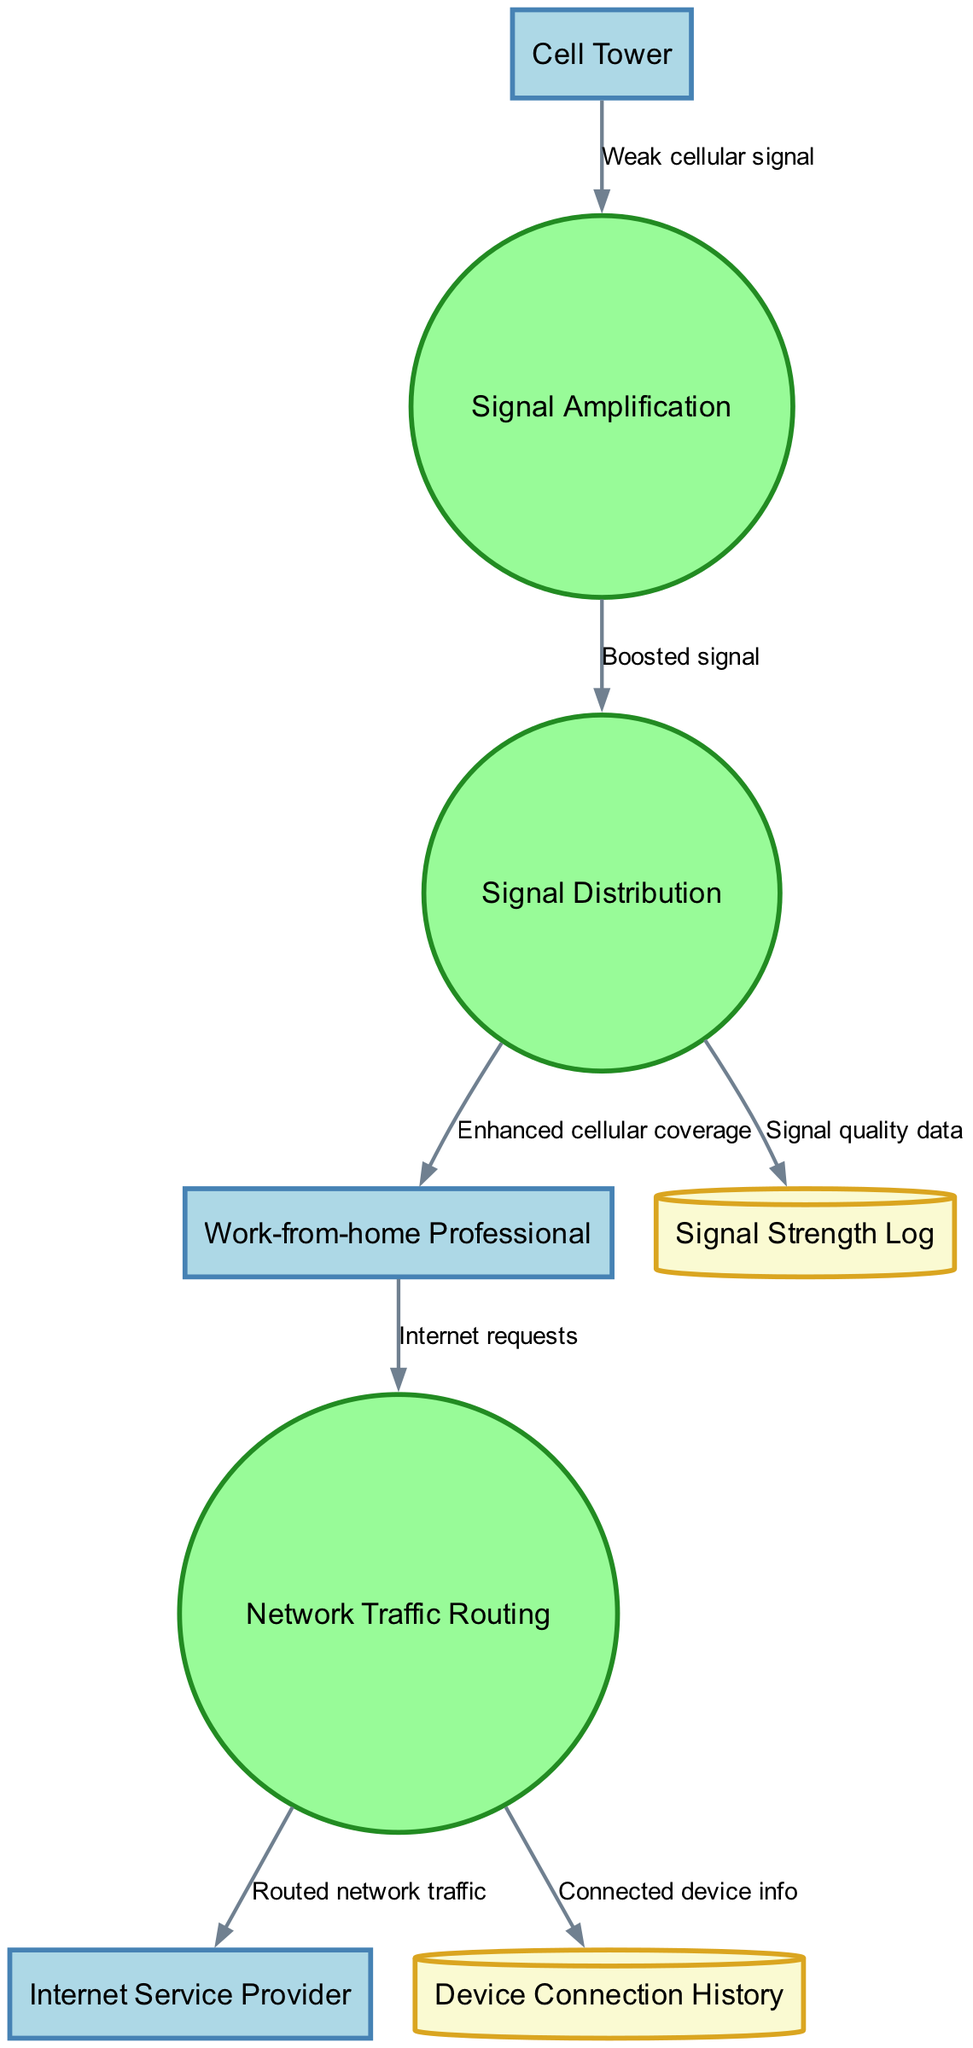What are the external entities in the diagram? The diagram lists three external entities: the Cell Tower, Internet Service Provider, and Work-from-home Professional. They are represented at the edges of the diagram, indicating their role in the cellular signal booster system.
Answer: Cell Tower, Internet Service Provider, Work-from-home Professional How many processes are there in the diagram? The diagram contains three processes, which are Signal Amplification, Signal Distribution, and Network Traffic Routing. They are depicted as circular nodes within the diagram.
Answer: 3 What is the output of the Signal Amplification process? The output of the Signal Amplification process is a Boosted signal, which flows directly to the Signal Distribution process. This is illustrated by the labeled data flow connecting the two nodes.
Answer: Boosted signal Which data store receives information from Signal Distribution? The Signal Strength Log receives signal quality data from the Signal Distribution process. This relationship is shown by the directed data flow from Signal Distribution labeled with "Signal quality data."
Answer: Signal Strength Log What type of data does the Work-from-home Professional send to Network Traffic Routing? The Work-from-home Professional sends Internet requests to Network Traffic Routing. This flow is indicated by the arrow labeled "Internet requests" connecting the two nodes.
Answer: Internet requests How does Network Traffic Routing interact with the Internet Service Provider? Network Traffic Routing sends Routed network traffic to the Internet Service Provider. This interaction is represented by the directed arrow between the two nodes labeled "Routed network traffic."
Answer: Routed network traffic What role does the Device Connection History play in the system? The Device Connection History stores Connected device info from Network Traffic Routing. This is shown by the directed data flow from Network Traffic Routing to the Device Connection History, indicating that it logs information about devices connected to the network.
Answer: Connected device info What is the first step in the data flow process? The first step in the data flow process is the reception of a Weak cellular signal from the Cell Tower, which is the initial input into the system for amplification. This is indicated by the arrow leading into the Signal Amplification process.
Answer: Weak cellular signal How many data stores are shown in the diagram? The diagram shows two data stores: the Signal Strength Log and the Device Connection History. These are represented as cylinder-shaped nodes within the diagram, indicating their function in storing information.
Answer: 2 